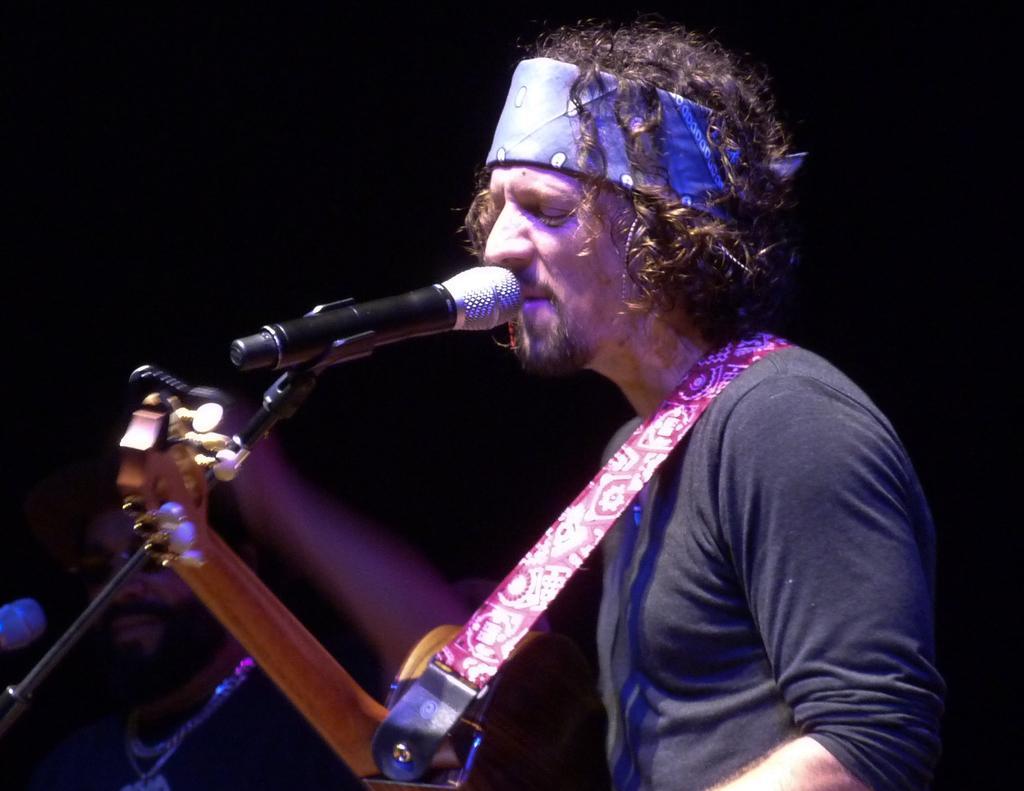Can you describe this image briefly? In this image i can see a person singing in front of a micro phone and holding some musical instrument. 